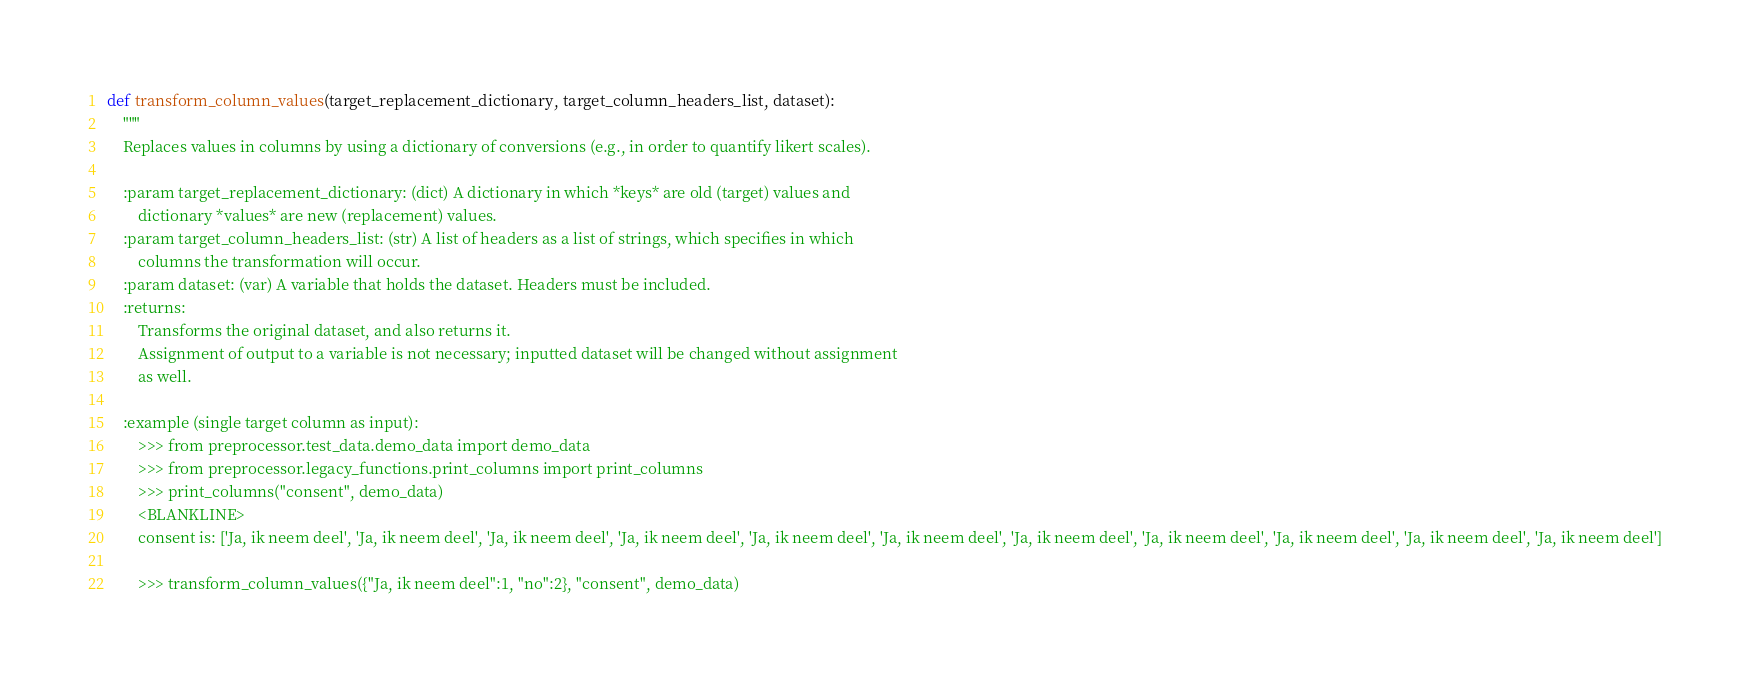<code> <loc_0><loc_0><loc_500><loc_500><_Python_>def transform_column_values(target_replacement_dictionary, target_column_headers_list, dataset):
    """
    Replaces values in columns by using a dictionary of conversions (e.g., in order to quantify likert scales).

    :param target_replacement_dictionary: (dict) A dictionary in which *keys* are old (target) values and
        dictionary *values* are new (replacement) values.
    :param target_column_headers_list: (str) A list of headers as a list of strings, which specifies in which
        columns the transformation will occur.
    :param dataset: (var) A variable that holds the dataset. Headers must be included.
    :returns:
        Transforms the original dataset, and also returns it.
        Assignment of output to a variable is not necessary; inputted dataset will be changed without assignment
        as well.

    :example (single target column as input):
        >>> from preprocessor.test_data.demo_data import demo_data
        >>> from preprocessor.legacy_functions.print_columns import print_columns
        >>> print_columns("consent", demo_data)
        <BLANKLINE>
        consent is: ['Ja, ik neem deel', 'Ja, ik neem deel', 'Ja, ik neem deel', 'Ja, ik neem deel', 'Ja, ik neem deel', 'Ja, ik neem deel', 'Ja, ik neem deel', 'Ja, ik neem deel', 'Ja, ik neem deel', 'Ja, ik neem deel', 'Ja, ik neem deel']

        >>> transform_column_values({"Ja, ik neem deel":1, "no":2}, "consent", demo_data)</code> 